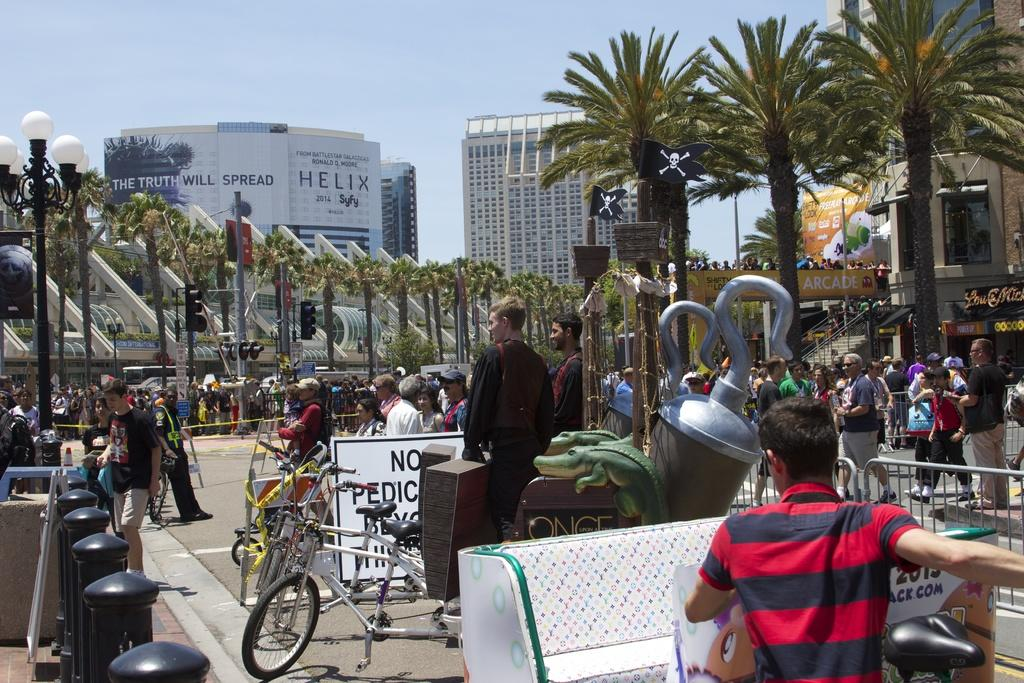<image>
Give a short and clear explanation of the subsequent image. A large white billboard in the distance with the word Helix written on it. 